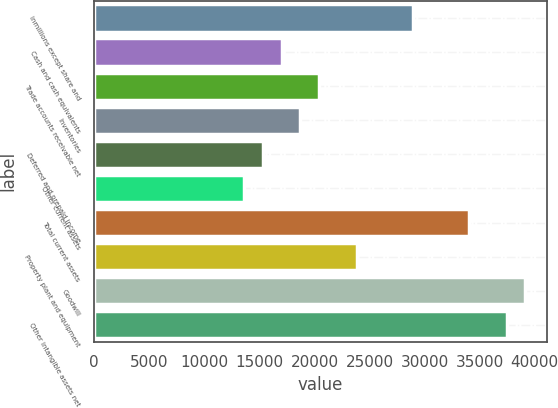<chart> <loc_0><loc_0><loc_500><loc_500><bar_chart><fcel>inmillions except share and<fcel>Cash and cash equivalents<fcel>Trade accounts receivable net<fcel>Inventories<fcel>Deferred and prepaid income<fcel>Other current assets<fcel>Total current assets<fcel>Property plant and equipment<fcel>Goodwill<fcel>Other intangible assets net<nl><fcel>28929.6<fcel>17024<fcel>20425.6<fcel>18724.8<fcel>15323.2<fcel>13622.4<fcel>34032<fcel>23827.2<fcel>39134.4<fcel>37433.6<nl></chart> 